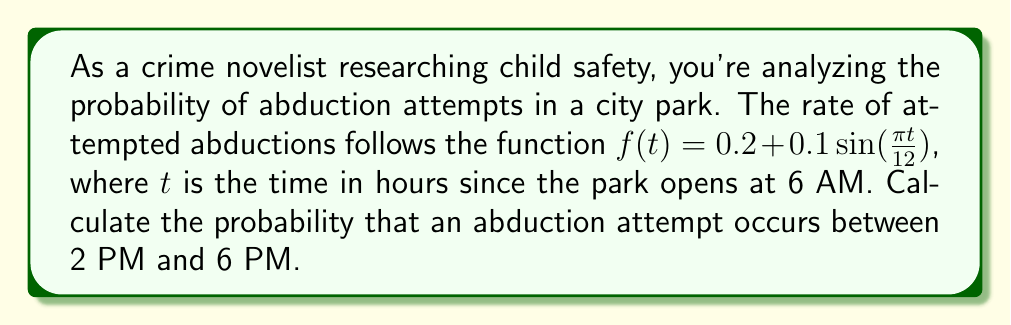Help me with this question. To solve this problem, we need to use integral calculus to find the area under the curve of the given function between the specified time interval.

Step 1: Set up the integral
The probability is given by the integral of $f(t)$ from $t=8$ (2 PM is 8 hours after 6 AM) to $t=12$ (6 PM is 12 hours after 6 AM):

$$P = \int_{8}^{12} [0.2 + 0.1\sin(\frac{\pi t}{12})] dt$$

Step 2: Integrate the function
$$\begin{align}
P &= [0.2t - \frac{1.2}{\pi}\cos(\frac{\pi t}{12})]_{8}^{12} \\
&= [0.2(12) - \frac{1.2}{\pi}\cos(\pi)] - [0.2(8) - \frac{1.2}{\pi}\cos(\frac{2\pi}{3})]
\end{align}$$

Step 3: Evaluate the expression
$$\begin{align}
P &= [2.4 + \frac{1.2}{\pi}] - [1.6 + \frac{1.2}{\pi}(-\frac{1}{2})] \\
&= 2.4 + \frac{1.2}{\pi} - 1.6 + \frac{0.6}{\pi} \\
&= 0.8 + \frac{1.8}{\pi} \\
&\approx 1.3728
\end{align}$$

The probability is approximately 1.3728, which is greater than 1. This indicates that an abduction attempt is almost certain to occur during this time period, with a possibility of multiple attempts.
Answer: $0.8 + \frac{1.8}{\pi} \approx 1.3728$ 